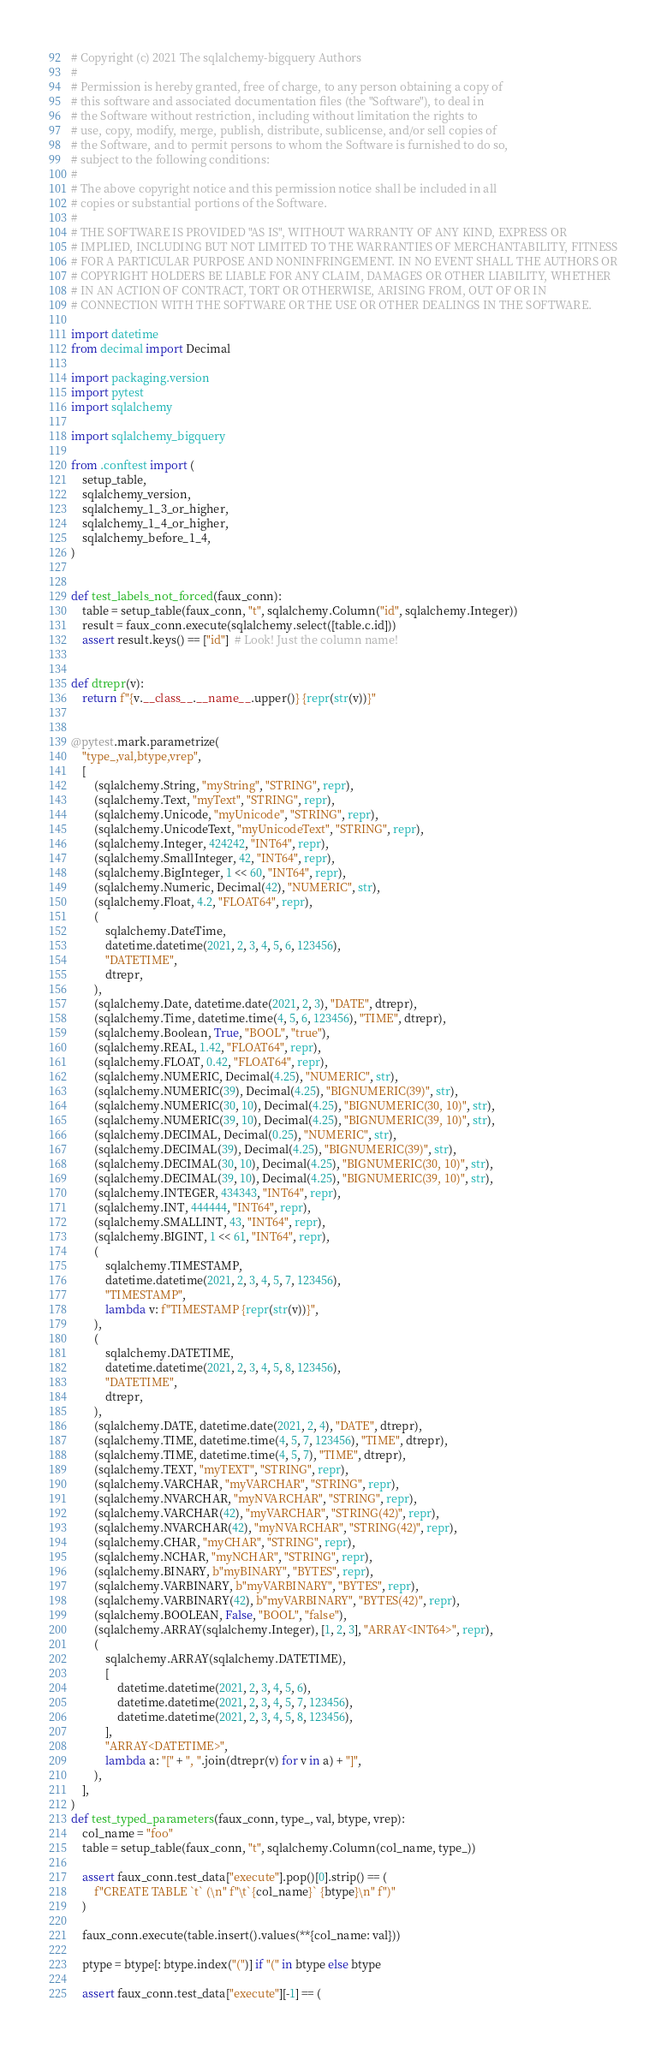<code> <loc_0><loc_0><loc_500><loc_500><_Python_># Copyright (c) 2021 The sqlalchemy-bigquery Authors
#
# Permission is hereby granted, free of charge, to any person obtaining a copy of
# this software and associated documentation files (the "Software"), to deal in
# the Software without restriction, including without limitation the rights to
# use, copy, modify, merge, publish, distribute, sublicense, and/or sell copies of
# the Software, and to permit persons to whom the Software is furnished to do so,
# subject to the following conditions:
#
# The above copyright notice and this permission notice shall be included in all
# copies or substantial portions of the Software.
#
# THE SOFTWARE IS PROVIDED "AS IS", WITHOUT WARRANTY OF ANY KIND, EXPRESS OR
# IMPLIED, INCLUDING BUT NOT LIMITED TO THE WARRANTIES OF MERCHANTABILITY, FITNESS
# FOR A PARTICULAR PURPOSE AND NONINFRINGEMENT. IN NO EVENT SHALL THE AUTHORS OR
# COPYRIGHT HOLDERS BE LIABLE FOR ANY CLAIM, DAMAGES OR OTHER LIABILITY, WHETHER
# IN AN ACTION OF CONTRACT, TORT OR OTHERWISE, ARISING FROM, OUT OF OR IN
# CONNECTION WITH THE SOFTWARE OR THE USE OR OTHER DEALINGS IN THE SOFTWARE.

import datetime
from decimal import Decimal

import packaging.version
import pytest
import sqlalchemy

import sqlalchemy_bigquery

from .conftest import (
    setup_table,
    sqlalchemy_version,
    sqlalchemy_1_3_or_higher,
    sqlalchemy_1_4_or_higher,
    sqlalchemy_before_1_4,
)


def test_labels_not_forced(faux_conn):
    table = setup_table(faux_conn, "t", sqlalchemy.Column("id", sqlalchemy.Integer))
    result = faux_conn.execute(sqlalchemy.select([table.c.id]))
    assert result.keys() == ["id"]  # Look! Just the column name!


def dtrepr(v):
    return f"{v.__class__.__name__.upper()} {repr(str(v))}"


@pytest.mark.parametrize(
    "type_,val,btype,vrep",
    [
        (sqlalchemy.String, "myString", "STRING", repr),
        (sqlalchemy.Text, "myText", "STRING", repr),
        (sqlalchemy.Unicode, "myUnicode", "STRING", repr),
        (sqlalchemy.UnicodeText, "myUnicodeText", "STRING", repr),
        (sqlalchemy.Integer, 424242, "INT64", repr),
        (sqlalchemy.SmallInteger, 42, "INT64", repr),
        (sqlalchemy.BigInteger, 1 << 60, "INT64", repr),
        (sqlalchemy.Numeric, Decimal(42), "NUMERIC", str),
        (sqlalchemy.Float, 4.2, "FLOAT64", repr),
        (
            sqlalchemy.DateTime,
            datetime.datetime(2021, 2, 3, 4, 5, 6, 123456),
            "DATETIME",
            dtrepr,
        ),
        (sqlalchemy.Date, datetime.date(2021, 2, 3), "DATE", dtrepr),
        (sqlalchemy.Time, datetime.time(4, 5, 6, 123456), "TIME", dtrepr),
        (sqlalchemy.Boolean, True, "BOOL", "true"),
        (sqlalchemy.REAL, 1.42, "FLOAT64", repr),
        (sqlalchemy.FLOAT, 0.42, "FLOAT64", repr),
        (sqlalchemy.NUMERIC, Decimal(4.25), "NUMERIC", str),
        (sqlalchemy.NUMERIC(39), Decimal(4.25), "BIGNUMERIC(39)", str),
        (sqlalchemy.NUMERIC(30, 10), Decimal(4.25), "BIGNUMERIC(30, 10)", str),
        (sqlalchemy.NUMERIC(39, 10), Decimal(4.25), "BIGNUMERIC(39, 10)", str),
        (sqlalchemy.DECIMAL, Decimal(0.25), "NUMERIC", str),
        (sqlalchemy.DECIMAL(39), Decimal(4.25), "BIGNUMERIC(39)", str),
        (sqlalchemy.DECIMAL(30, 10), Decimal(4.25), "BIGNUMERIC(30, 10)", str),
        (sqlalchemy.DECIMAL(39, 10), Decimal(4.25), "BIGNUMERIC(39, 10)", str),
        (sqlalchemy.INTEGER, 434343, "INT64", repr),
        (sqlalchemy.INT, 444444, "INT64", repr),
        (sqlalchemy.SMALLINT, 43, "INT64", repr),
        (sqlalchemy.BIGINT, 1 << 61, "INT64", repr),
        (
            sqlalchemy.TIMESTAMP,
            datetime.datetime(2021, 2, 3, 4, 5, 7, 123456),
            "TIMESTAMP",
            lambda v: f"TIMESTAMP {repr(str(v))}",
        ),
        (
            sqlalchemy.DATETIME,
            datetime.datetime(2021, 2, 3, 4, 5, 8, 123456),
            "DATETIME",
            dtrepr,
        ),
        (sqlalchemy.DATE, datetime.date(2021, 2, 4), "DATE", dtrepr),
        (sqlalchemy.TIME, datetime.time(4, 5, 7, 123456), "TIME", dtrepr),
        (sqlalchemy.TIME, datetime.time(4, 5, 7), "TIME", dtrepr),
        (sqlalchemy.TEXT, "myTEXT", "STRING", repr),
        (sqlalchemy.VARCHAR, "myVARCHAR", "STRING", repr),
        (sqlalchemy.NVARCHAR, "myNVARCHAR", "STRING", repr),
        (sqlalchemy.VARCHAR(42), "myVARCHAR", "STRING(42)", repr),
        (sqlalchemy.NVARCHAR(42), "myNVARCHAR", "STRING(42)", repr),
        (sqlalchemy.CHAR, "myCHAR", "STRING", repr),
        (sqlalchemy.NCHAR, "myNCHAR", "STRING", repr),
        (sqlalchemy.BINARY, b"myBINARY", "BYTES", repr),
        (sqlalchemy.VARBINARY, b"myVARBINARY", "BYTES", repr),
        (sqlalchemy.VARBINARY(42), b"myVARBINARY", "BYTES(42)", repr),
        (sqlalchemy.BOOLEAN, False, "BOOL", "false"),
        (sqlalchemy.ARRAY(sqlalchemy.Integer), [1, 2, 3], "ARRAY<INT64>", repr),
        (
            sqlalchemy.ARRAY(sqlalchemy.DATETIME),
            [
                datetime.datetime(2021, 2, 3, 4, 5, 6),
                datetime.datetime(2021, 2, 3, 4, 5, 7, 123456),
                datetime.datetime(2021, 2, 3, 4, 5, 8, 123456),
            ],
            "ARRAY<DATETIME>",
            lambda a: "[" + ", ".join(dtrepr(v) for v in a) + "]",
        ),
    ],
)
def test_typed_parameters(faux_conn, type_, val, btype, vrep):
    col_name = "foo"
    table = setup_table(faux_conn, "t", sqlalchemy.Column(col_name, type_))

    assert faux_conn.test_data["execute"].pop()[0].strip() == (
        f"CREATE TABLE `t` (\n" f"\t`{col_name}` {btype}\n" f")"
    )

    faux_conn.execute(table.insert().values(**{col_name: val}))

    ptype = btype[: btype.index("(")] if "(" in btype else btype

    assert faux_conn.test_data["execute"][-1] == (</code> 